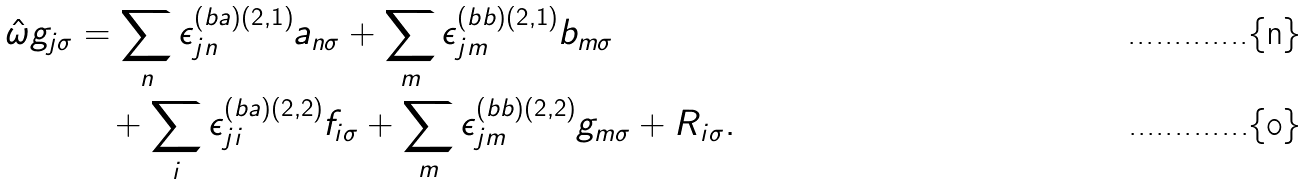<formula> <loc_0><loc_0><loc_500><loc_500>\hat { \omega } g _ { j \sigma } & = \sum _ { n } \epsilon ^ { ( b a ) ( 2 , 1 ) } _ { j n } a _ { n \sigma } + \sum _ { m } \epsilon ^ { ( b b ) ( 2 , 1 ) } _ { j m } b _ { m \sigma } \\ & \quad + \sum _ { i } \epsilon ^ { ( b a ) ( 2 , 2 ) } _ { j i } f _ { i \sigma } + \sum _ { m } \epsilon ^ { ( b b ) ( 2 , 2 ) } _ { j m } g _ { m \sigma } + R _ { i \sigma } .</formula> 